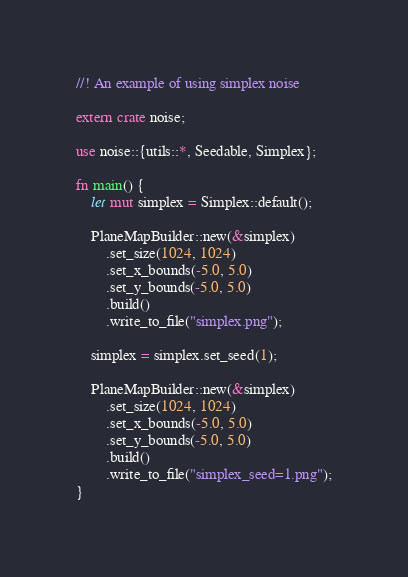<code> <loc_0><loc_0><loc_500><loc_500><_Rust_>//! An example of using simplex noise

extern crate noise;

use noise::{utils::*, Seedable, Simplex};

fn main() {
    let mut simplex = Simplex::default();

    PlaneMapBuilder::new(&simplex)
        .set_size(1024, 1024)
        .set_x_bounds(-5.0, 5.0)
        .set_y_bounds(-5.0, 5.0)
        .build()
        .write_to_file("simplex.png");

    simplex = simplex.set_seed(1);

    PlaneMapBuilder::new(&simplex)
        .set_size(1024, 1024)
        .set_x_bounds(-5.0, 5.0)
        .set_y_bounds(-5.0, 5.0)
        .build()
        .write_to_file("simplex_seed=1.png");
}
</code> 